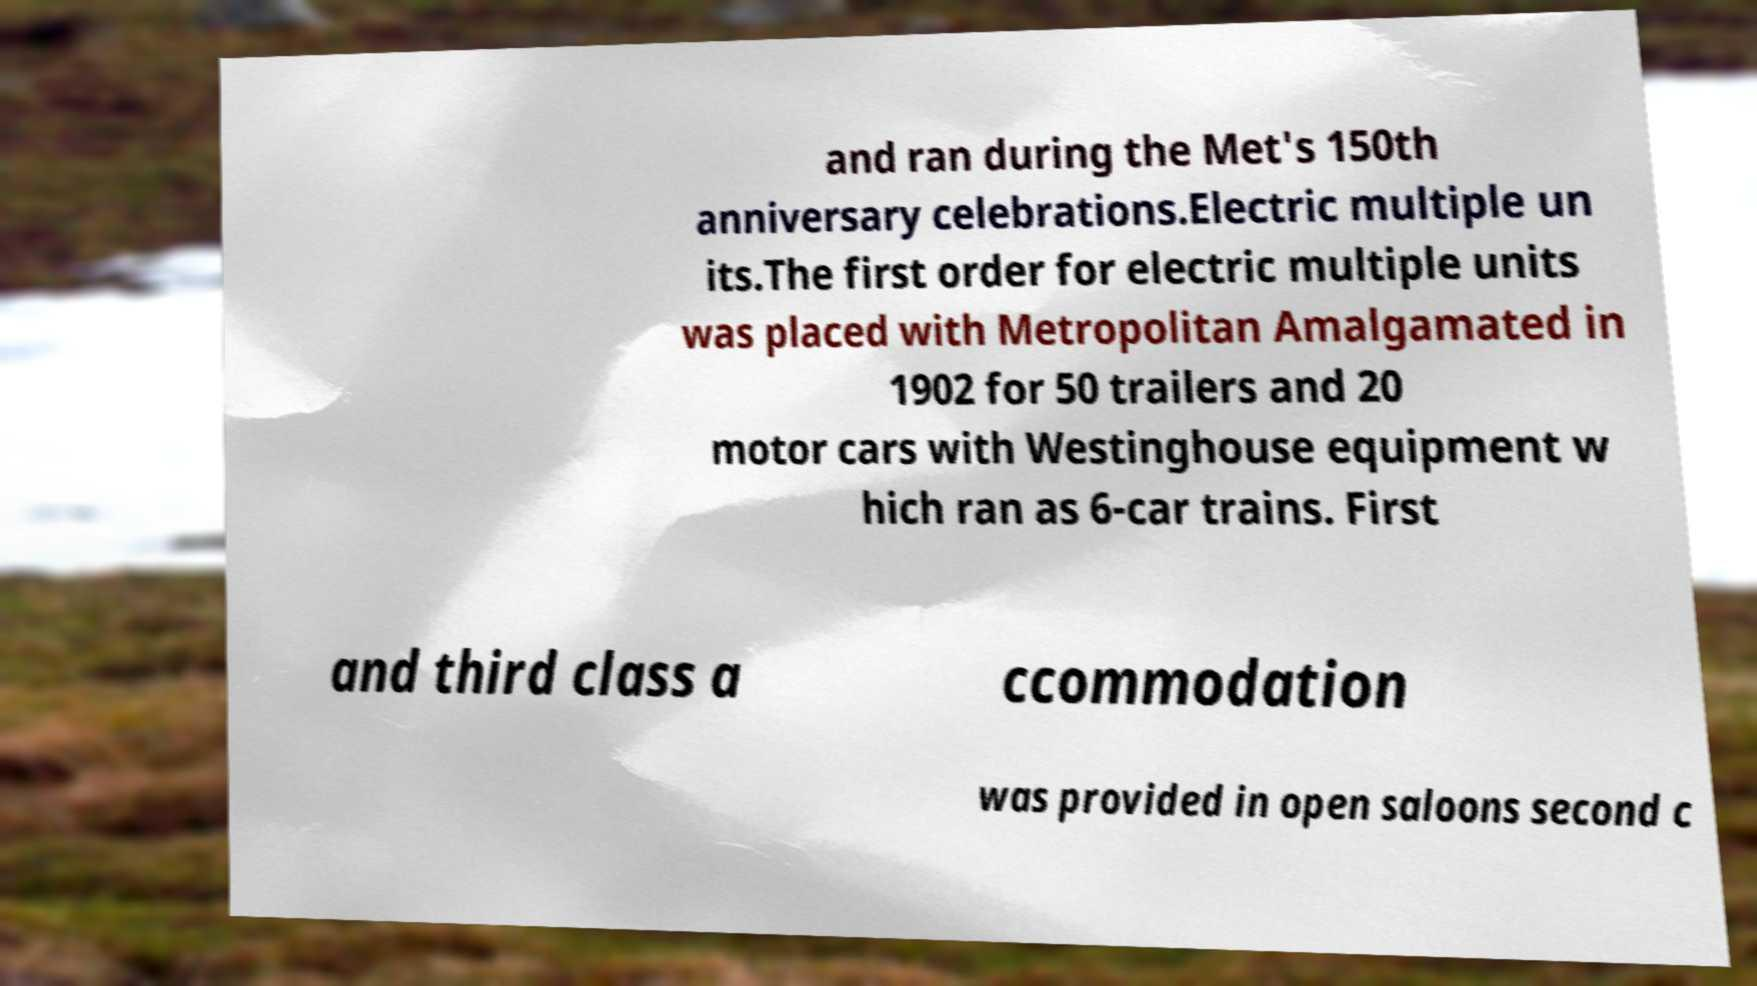Could you assist in decoding the text presented in this image and type it out clearly? and ran during the Met's 150th anniversary celebrations.Electric multiple un its.The first order for electric multiple units was placed with Metropolitan Amalgamated in 1902 for 50 trailers and 20 motor cars with Westinghouse equipment w hich ran as 6-car trains. First and third class a ccommodation was provided in open saloons second c 